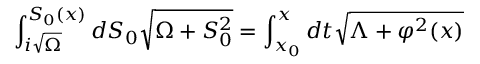Convert formula to latex. <formula><loc_0><loc_0><loc_500><loc_500>\int _ { i \sqrt { \Omega } } ^ { S _ { 0 } ( x ) } { d S _ { 0 } \sqrt { \Omega + S _ { 0 } ^ { 2 } } } = \int _ { x _ { 0 } } ^ { x } { d t \sqrt { \Lambda + \varphi ^ { 2 } ( x ) } }</formula> 